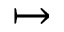<formula> <loc_0><loc_0><loc_500><loc_500>\mapsto</formula> 